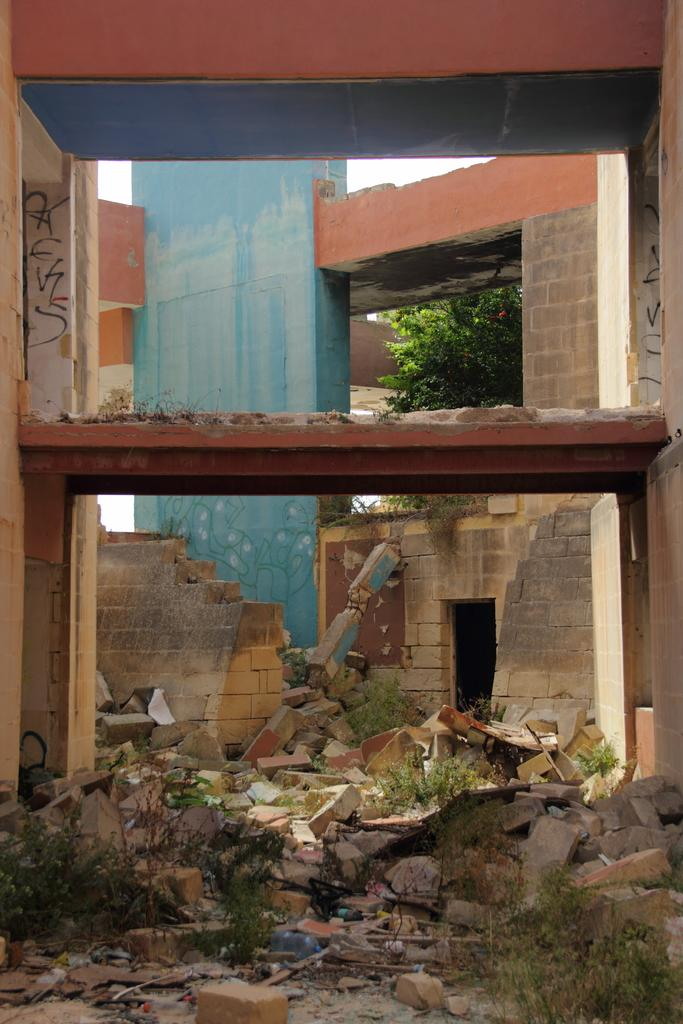What is located at the bottom of the image? There are bricks and plants at the bottom of the image. What can be seen in the background of the image? There is a building, stairs, and a tree in the background of the image. How many times do the plants sneeze in the image? Plants do not have the ability to sneeze, so this question cannot be answered. What color are the eyes of the tree in the image? Trees do not have eyes, so this question cannot be answered. 